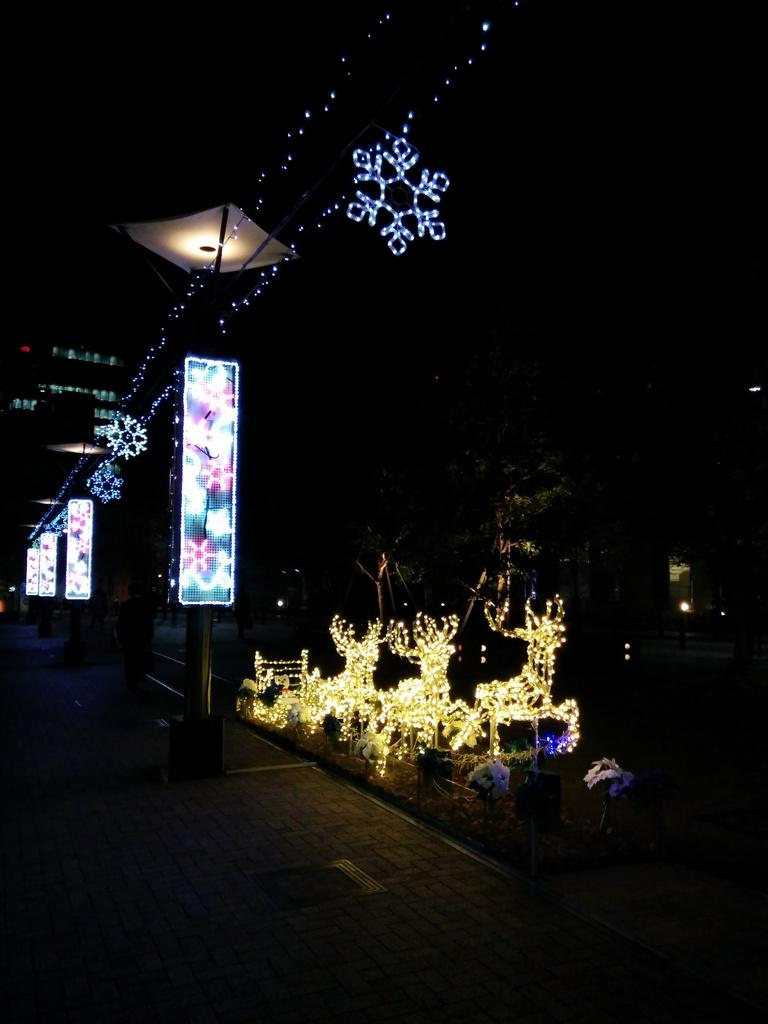What natural phenomenon can be seen in the image? There are lightnings in the image. What type of vegetation is visible in the background of the image? There are trees in the background of the image. What type of structure can be seen in the background of the image? There is a building in the background of the image. What color is the sack that the partner is carrying in the image? There is no sack or partner present in the image. 